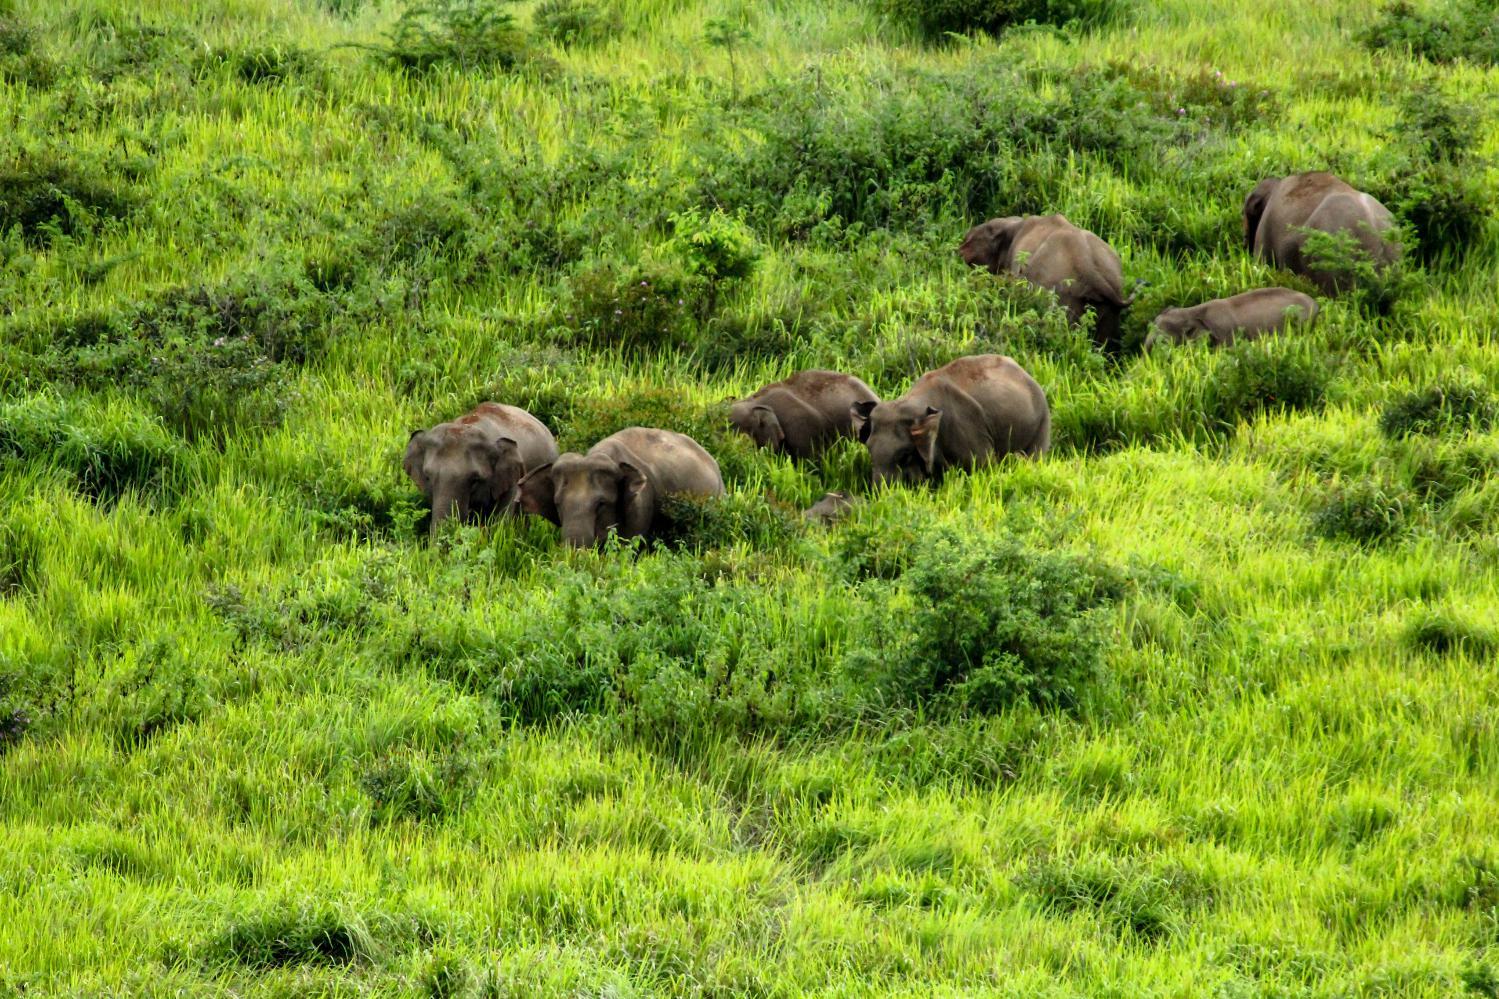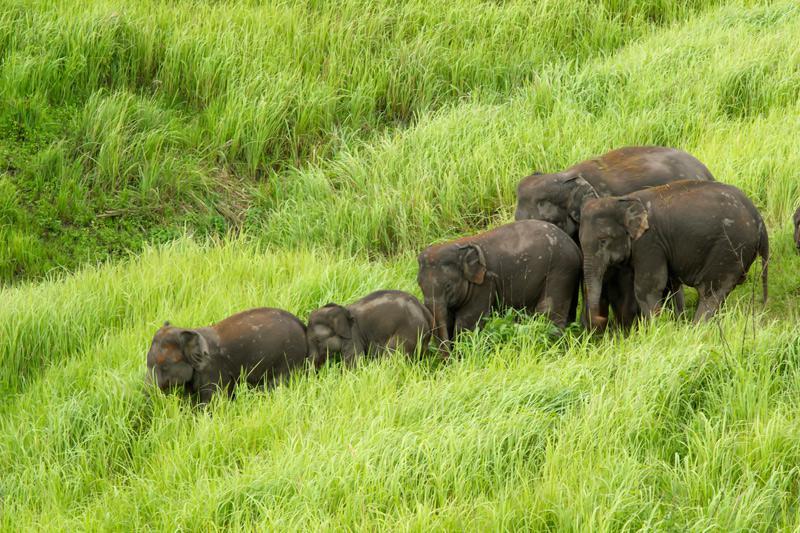The first image is the image on the left, the second image is the image on the right. Given the left and right images, does the statement "There are no more than 4 elephants in the image pair" hold true? Answer yes or no. No. The first image is the image on the left, the second image is the image on the right. Examine the images to the left and right. Is the description "There are at least six elephants." accurate? Answer yes or no. Yes. 